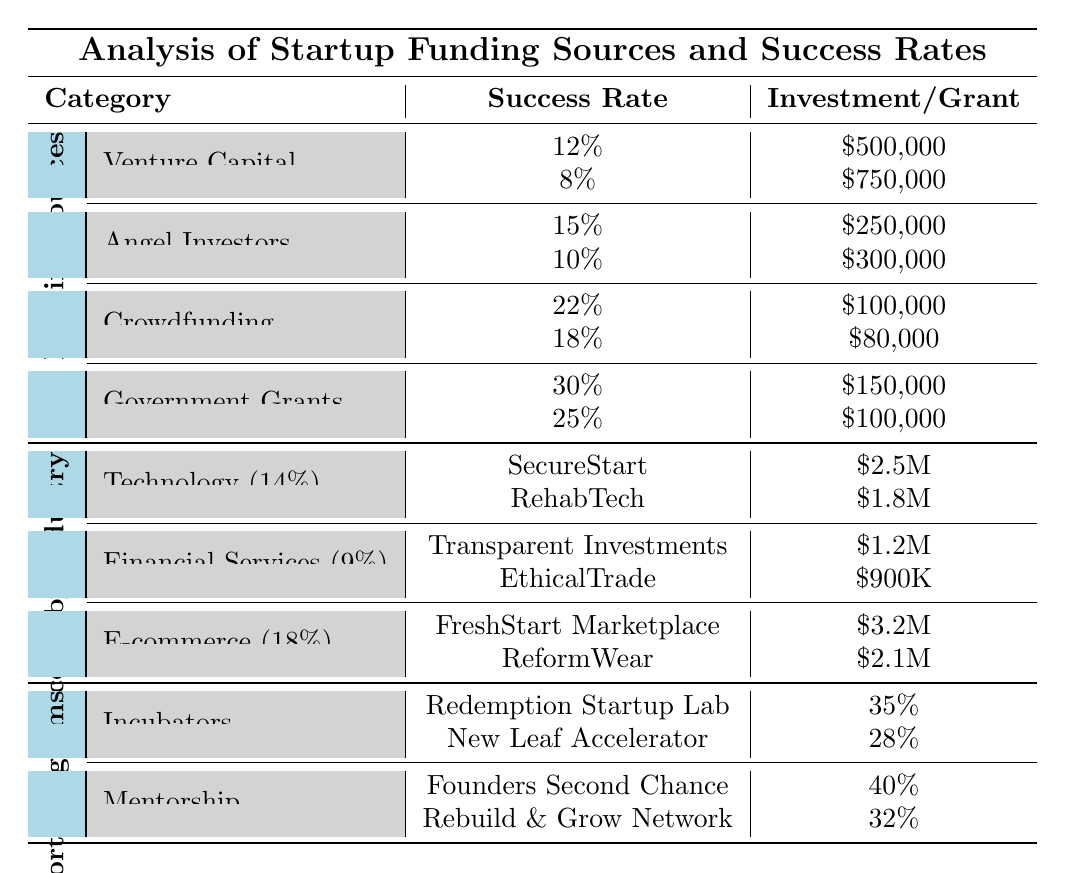What is the highest success rate among the funding sources listed? The highest success rate among the funding sources is 30% from Government Grants (SBA Reentry Entrepreneurship Program).
Answer: 30% Which funding source has the lowest average investment? Crowdfunding has the lowest average raise of $90,000 from its platforms. The minimum amount raised is $80,000 at RebuildMe.
Answer: $80,000 What is the overall success rate for the E-commerce industry? The table states that the overall success rate for the E-commerce industry is 18%.
Answer: 18% What is the average success rate of all the listed support programs? The success rates for the support programs are 35%, 28%, 40%, and 32%. The average is calculated as (35 + 28 + 40 + 32) / 4 = 35%.
Answer: 35% Which entrepreneurial category has a lower average success rate: Technology or Financial Services? The overall success rate for Technology is 14%, while it is 9% for Financial Services, indicating that Financial Services has a lower average success rate.
Answer: Financial Services How much funding did the top performer in E-commerce raise? The top performer in E-commerce is FreshStart Marketplace, which raised $3.2 million.
Answer: $3.2 million Are there more mentorship programs or incubator programs listed in the table? There are 2 mentorship programs (Founders Second Chance and Rebuild & Grow Network) and 2 incubator programs (Redemption Startup Lab and New Leaf Accelerator), so their count is the same.
Answer: No, they are equal What is the cumulative success rate of the Angel Investors category? The cumulative success rates for Angel Investors are 15% and 10%. Adding these gives 15% + 10% = 25%. The cumulative rate for Angel Investors is therefore 25%.
Answer: 25% Which company raised more funding: SecureStart Cybersecurity or FreshStart Marketplace? SecureStart Cybersecurity raised $2.5 million while FreshStart Marketplace raised $3.2 million, indicating FreshStart raised more.
Answer: FreshStart Marketplace What is the success rate for the Department of Labor HIRE Program? The success rate for the Department of Labor HIRE Program listed under Government Grants is 25%.
Answer: 25% 